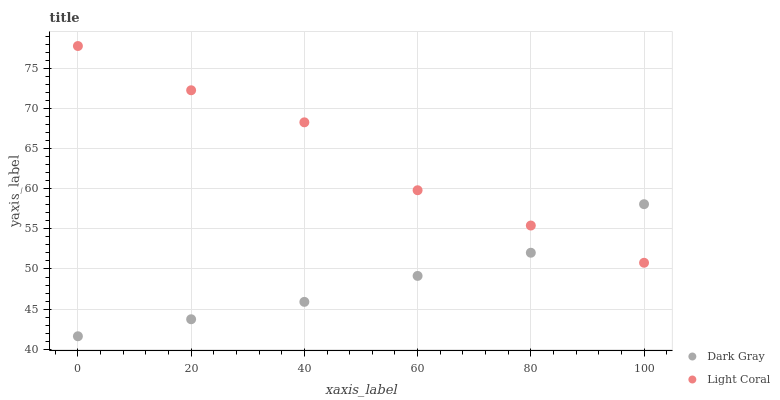Does Dark Gray have the minimum area under the curve?
Answer yes or no. Yes. Does Light Coral have the maximum area under the curve?
Answer yes or no. Yes. Does Light Coral have the minimum area under the curve?
Answer yes or no. No. Is Dark Gray the smoothest?
Answer yes or no. Yes. Is Light Coral the roughest?
Answer yes or no. Yes. Is Light Coral the smoothest?
Answer yes or no. No. Does Dark Gray have the lowest value?
Answer yes or no. Yes. Does Light Coral have the lowest value?
Answer yes or no. No. Does Light Coral have the highest value?
Answer yes or no. Yes. Does Dark Gray intersect Light Coral?
Answer yes or no. Yes. Is Dark Gray less than Light Coral?
Answer yes or no. No. Is Dark Gray greater than Light Coral?
Answer yes or no. No. 